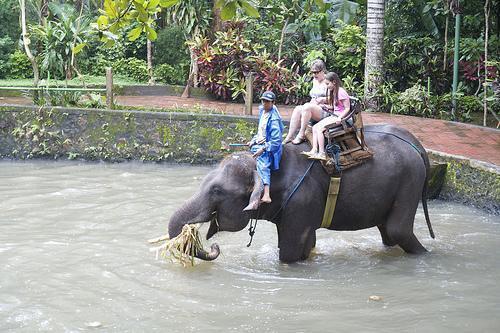How many elephants are there?
Give a very brief answer. 1. 